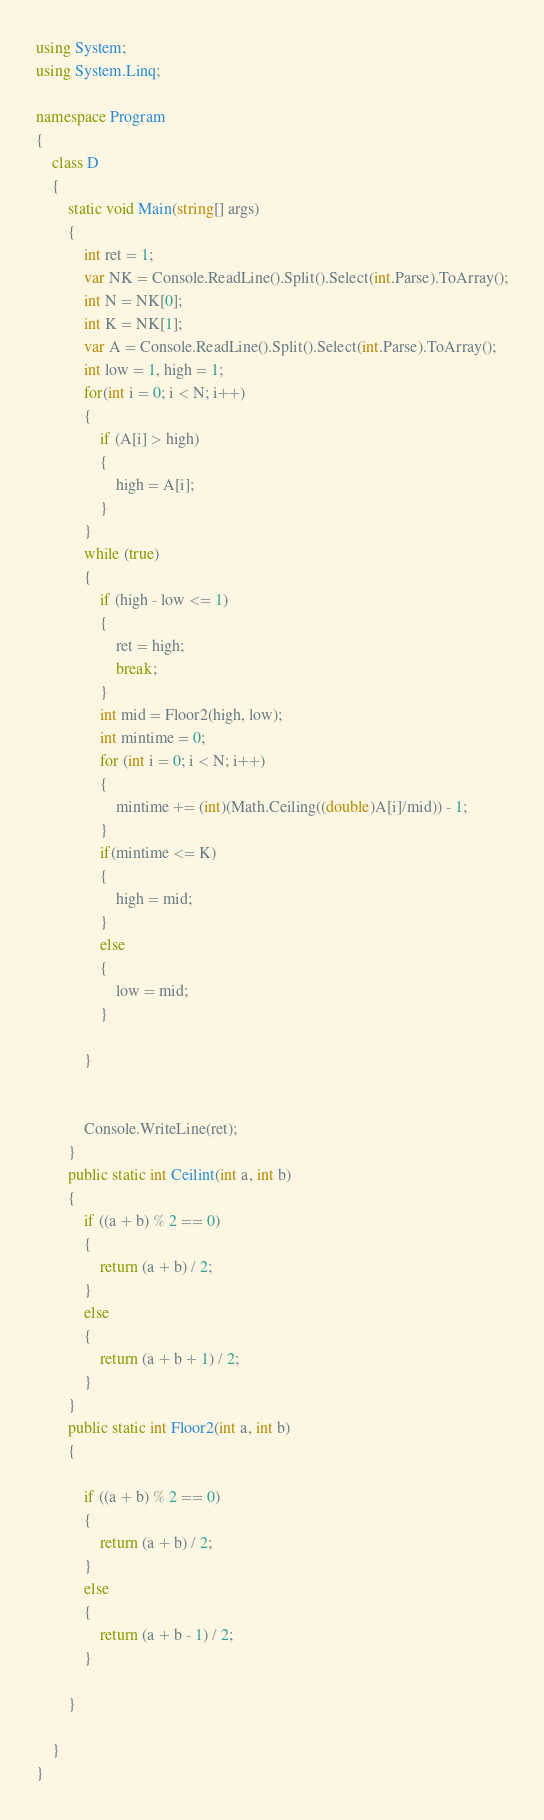Convert code to text. <code><loc_0><loc_0><loc_500><loc_500><_C#_>using System;
using System.Linq;

namespace Program
{
    class D
    {
        static void Main(string[] args)
        {
            int ret = 1;
            var NK = Console.ReadLine().Split().Select(int.Parse).ToArray();
            int N = NK[0];
            int K = NK[1];
            var A = Console.ReadLine().Split().Select(int.Parse).ToArray();
            int low = 1, high = 1;
            for(int i = 0; i < N; i++)
            {
                if (A[i] > high)
                {
                    high = A[i];
                }
            }
            while (true)
            {
                if (high - low <= 1)
                {
                    ret = high;
                    break;
                }
                int mid = Floor2(high, low);
                int mintime = 0;
                for (int i = 0; i < N; i++)
                {
                    mintime += (int)(Math.Ceiling((double)A[i]/mid)) - 1;
                }
                if(mintime <= K)
                {
                    high = mid;
                }
                else
                {
                    low = mid;
                }
                
            }


            Console.WriteLine(ret);
        }
        public static int Ceilint(int a, int b)
        {
            if ((a + b) % 2 == 0)
            {
                return (a + b) / 2;
            }
            else
            {
                return (a + b + 1) / 2;
            }
        }
        public static int Floor2(int a, int b)
        {

            if ((a + b) % 2 == 0)
            {
                return (a + b) / 2;
            }
            else
            {
                return (a + b - 1) / 2;
            }

        }

    }
}
</code> 